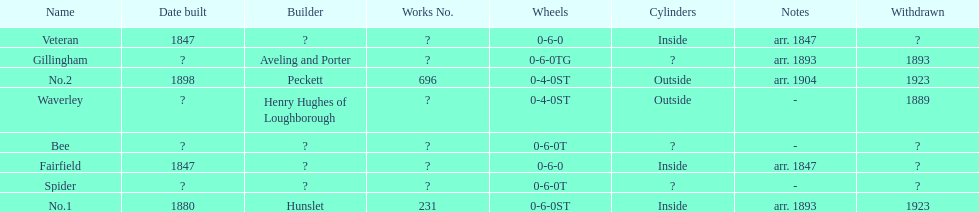Was no.1 or veteran built in 1847? Veteran. 